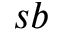<formula> <loc_0><loc_0><loc_500><loc_500>s b</formula> 